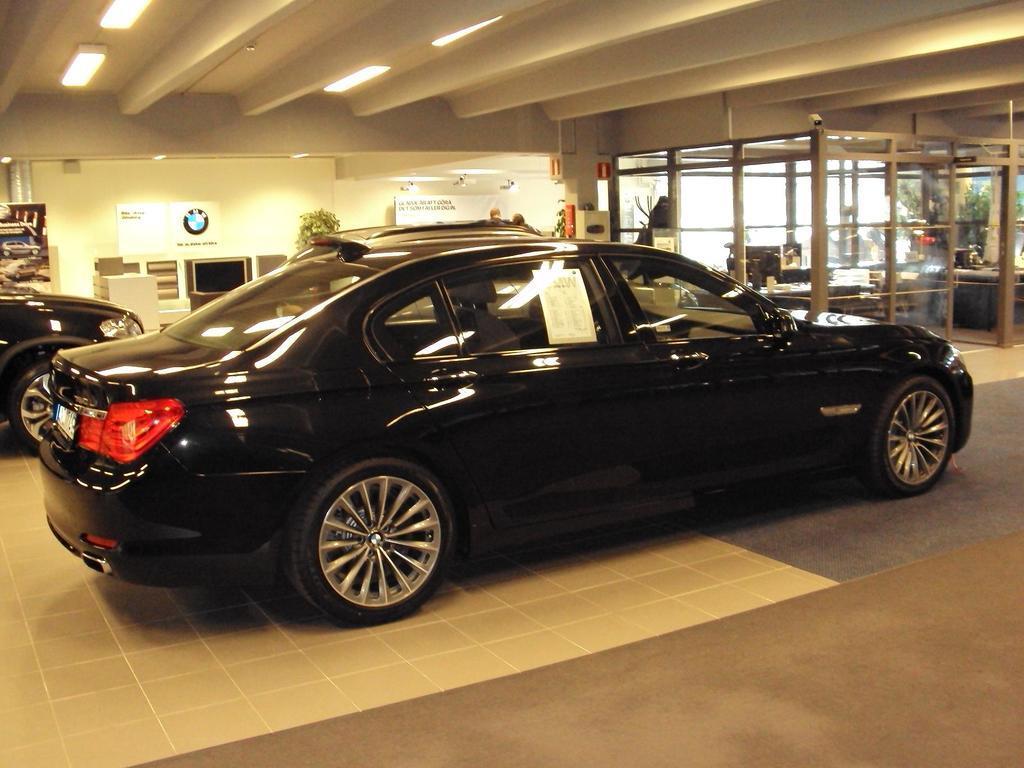Can you describe this image briefly? In this picture we can see few cars, in the background we can find few trees, lights and posters on the wall. 